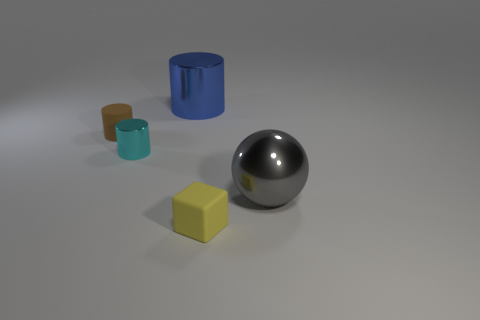What material is the cylinder in front of the matte thing behind the large object on the right side of the small yellow matte block made of? metal 